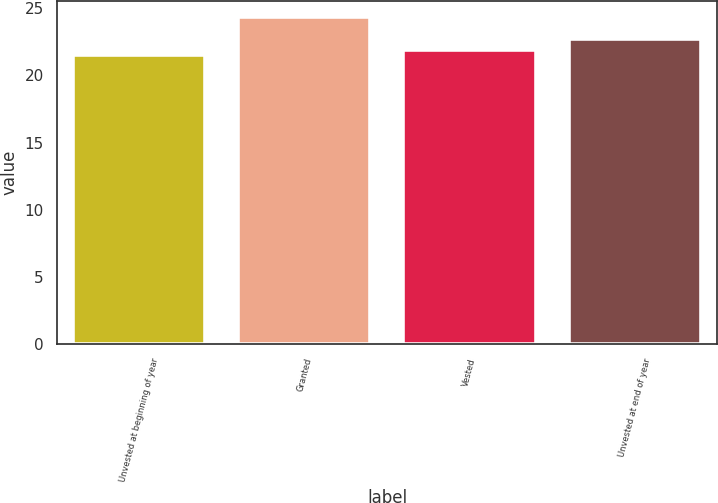<chart> <loc_0><loc_0><loc_500><loc_500><bar_chart><fcel>Unvested at beginning of year<fcel>Granted<fcel>Vested<fcel>Unvested at end of year<nl><fcel>21.53<fcel>24.31<fcel>21.86<fcel>22.69<nl></chart> 